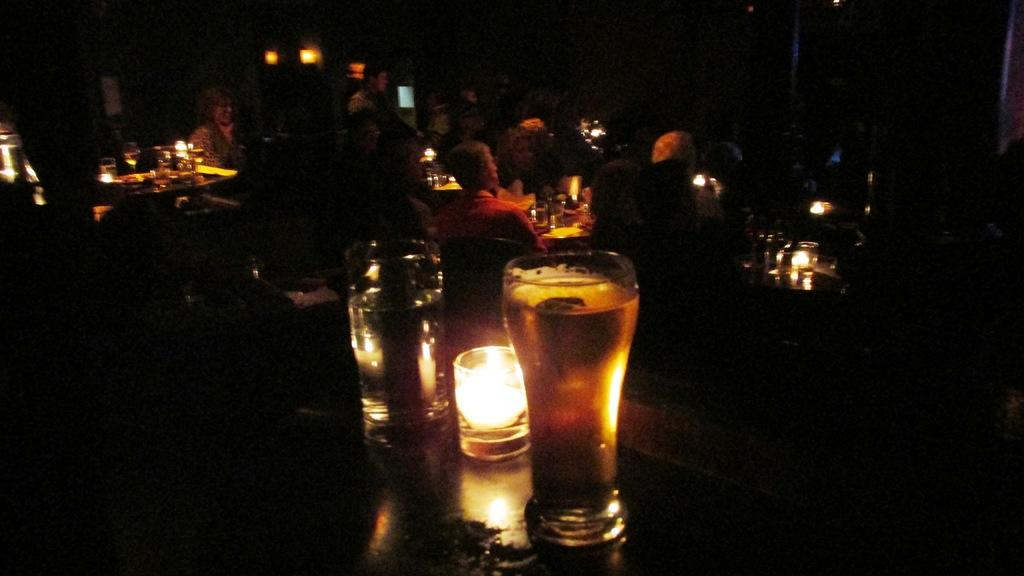How many people are visible in the image? There are many people in the image. What is located in the front of the image? There is a glass of beer in the front of the image. What type of furniture can be seen in the background of the image? There are tables and chairs in the background of the image. What is the lighting like in the image? The room appears to be dark. What type of establishment might the setting resemble? The setting resembles a restaurant. Can you see any roses on the table in the image? There are no roses visible in the image. What type of crow is sitting on the chair in the image? There are no crows present in the image. 